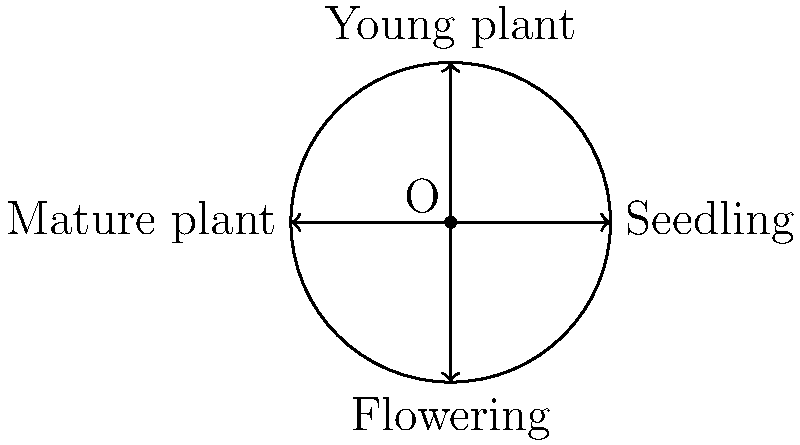Consider the life cycle of a Hypericum plant represented on a unit circle, where each stage is mapped to a point on the circle. The seedling stage is at (1,0), young plant at (0,1), mature plant at (-1,0), and flowering at (0,-1). If we apply a rotation of 90° clockwise followed by a reflection over the y-axis, what transformation would bring the plant from the seedling stage directly to the flowering stage? Let's approach this step-by-step:

1) First, let's consider the initial rotation of 90° clockwise:
   - This moves the point from (1,0) to (0,-1)
   - In matrix form, this is represented by $$\begin{pmatrix} 0 & 1 \\ -1 & 0 \end{pmatrix}$$

2) Next, we apply a reflection over the y-axis:
   - This changes the point from (0,-1) to (0,-1)
   - The matrix for this transformation is $$\begin{pmatrix} -1 & 0 \\ 0 & 1 \end{pmatrix}$$

3) The composition of these transformations is:
   $$\begin{pmatrix} -1 & 0 \\ 0 & 1 \end{pmatrix} \cdot \begin{pmatrix} 0 & 1 \\ -1 & 0 \end{pmatrix} = \begin{pmatrix} 0 & -1 \\ -1 & 0 \end{pmatrix}$$

4) This resultant matrix represents a rotation by 270° counterclockwise (or 90° clockwise) followed by a reflection over the line y = x.

5) However, to go directly from seedling (1,0) to flowering (0,-1), we can simply use a rotation of 270° counterclockwise (or 90° clockwise).

6) The matrix for this direct transformation is $$\begin{pmatrix} 0 & 1 \\ -1 & 0 \end{pmatrix}$$

Therefore, the single transformation that would bring the plant directly from seedling to flowering stage is a rotation of 270° counterclockwise (or 90° clockwise).
Answer: Rotation of 270° counterclockwise 